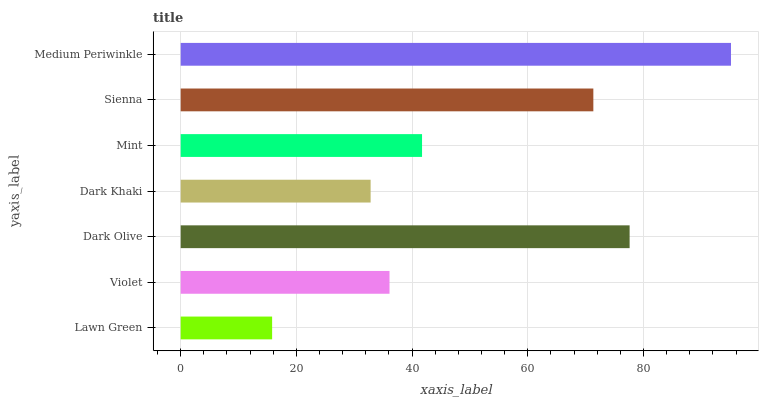Is Lawn Green the minimum?
Answer yes or no. Yes. Is Medium Periwinkle the maximum?
Answer yes or no. Yes. Is Violet the minimum?
Answer yes or no. No. Is Violet the maximum?
Answer yes or no. No. Is Violet greater than Lawn Green?
Answer yes or no. Yes. Is Lawn Green less than Violet?
Answer yes or no. Yes. Is Lawn Green greater than Violet?
Answer yes or no. No. Is Violet less than Lawn Green?
Answer yes or no. No. Is Mint the high median?
Answer yes or no. Yes. Is Mint the low median?
Answer yes or no. Yes. Is Dark Khaki the high median?
Answer yes or no. No. Is Sienna the low median?
Answer yes or no. No. 